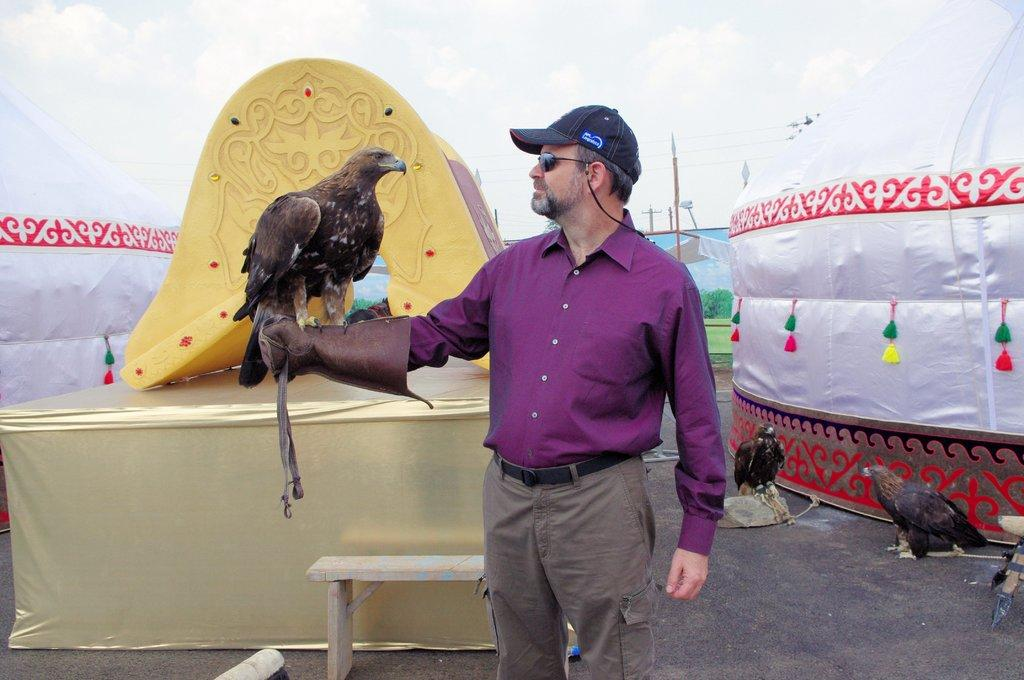Where was the image taken? The image is taken outdoors. Who is present in the image? There is a man in the image. What is the man doing in the image? The man is standing on a road and holding a bird. What can be seen in the background of the image? There is a tent in the background of the image, and the sky is visible as well. What color is the tent in the image? The tent is white in color. Can you tell me how many kitties are playing with the bird in the image? There are no kitties present in the image; the man is holding a bird. What type of birth is being celebrated in the image? There is no indication of a celebration or a birth in the image. 